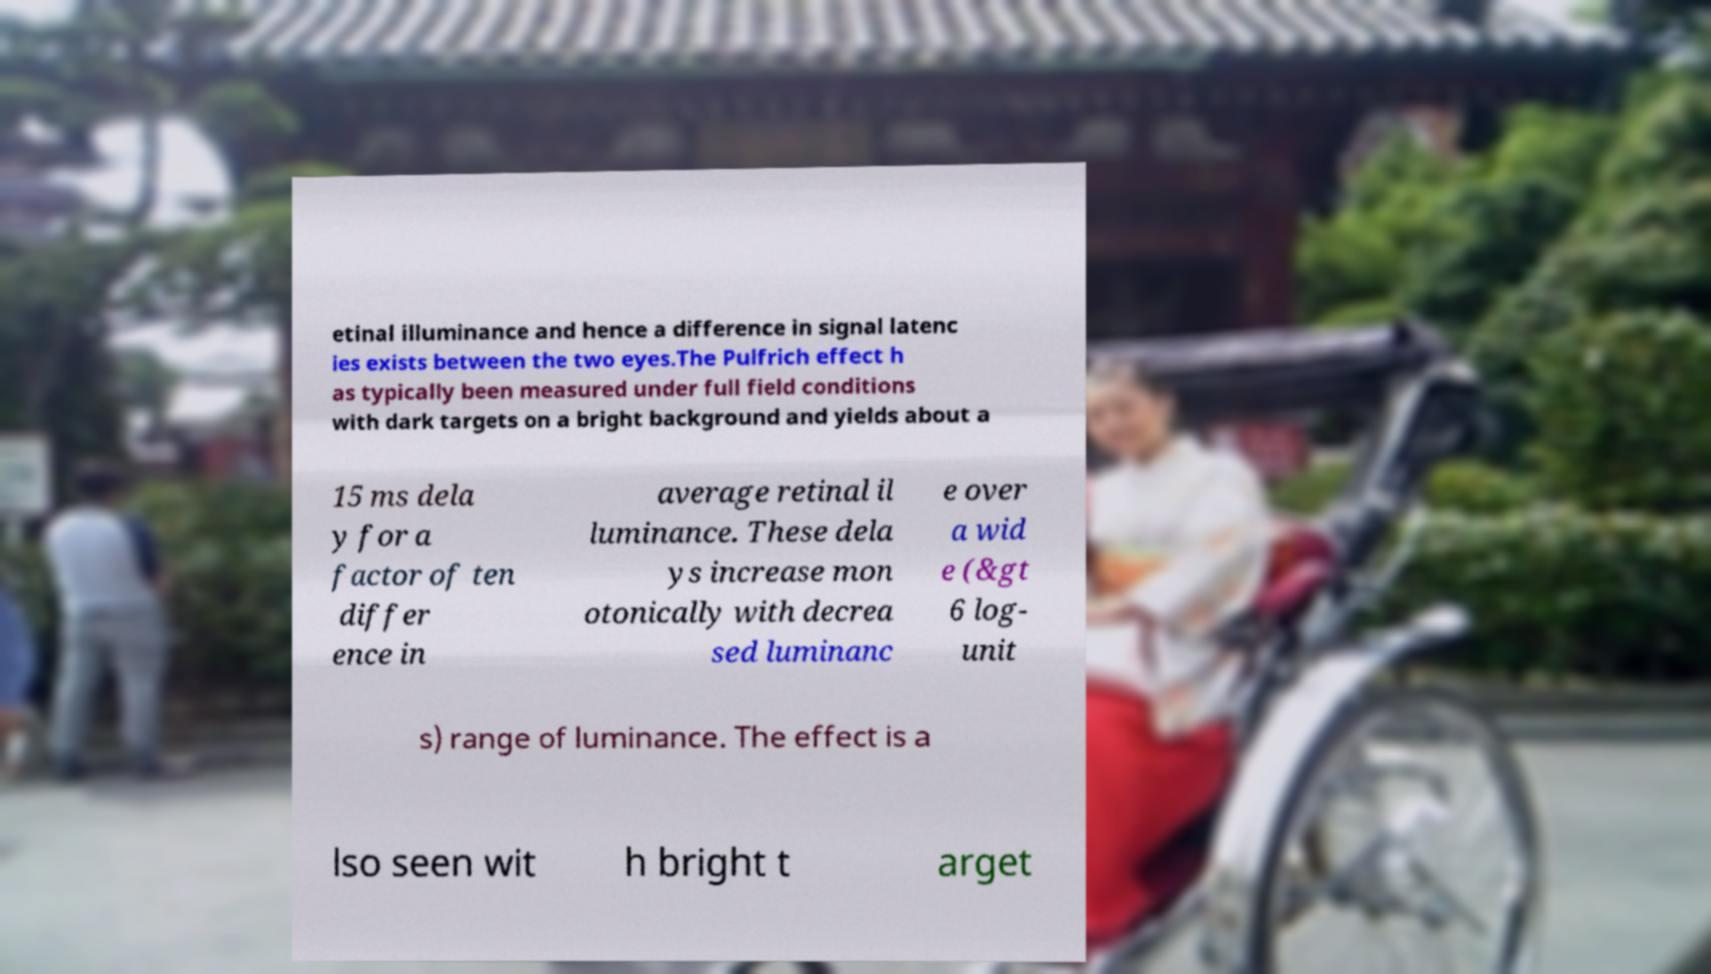I need the written content from this picture converted into text. Can you do that? etinal illuminance and hence a difference in signal latenc ies exists between the two eyes.The Pulfrich effect h as typically been measured under full field conditions with dark targets on a bright background and yields about a 15 ms dela y for a factor of ten differ ence in average retinal il luminance. These dela ys increase mon otonically with decrea sed luminanc e over a wid e (&gt 6 log- unit s) range of luminance. The effect is a lso seen wit h bright t arget 